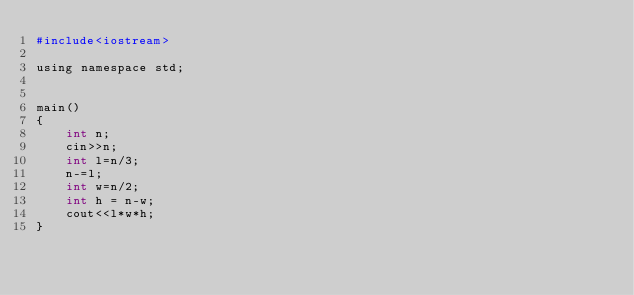<code> <loc_0><loc_0><loc_500><loc_500><_Python_>#include<iostream>

using namespace std;


main()
{
    int n;
    cin>>n;
    int l=n/3;
    n-=l;
    int w=n/2;
    int h = n-w;
    cout<<l*w*h;
}

</code> 